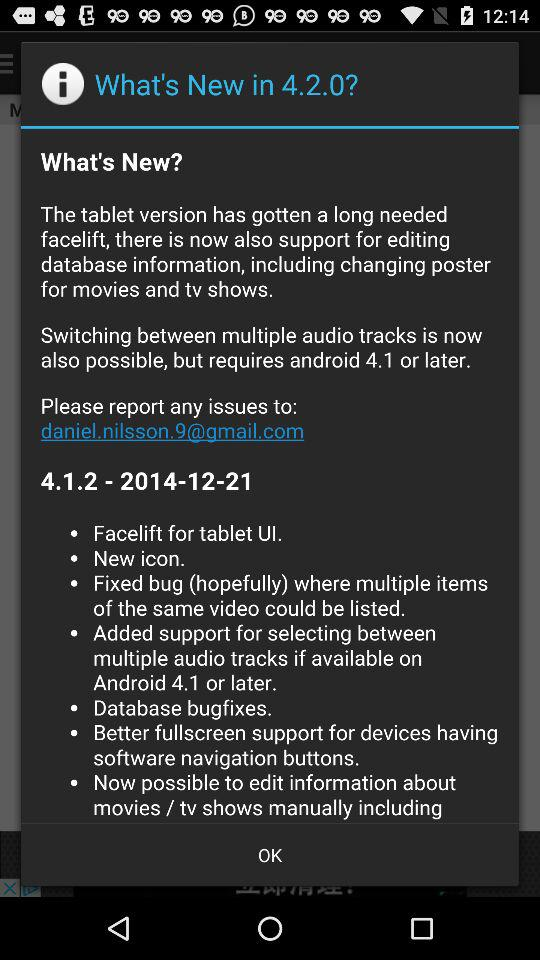What email address should be used to report any issues? The email address that should be used to report any issues is daniel.nilsson.9@gmail.com. 